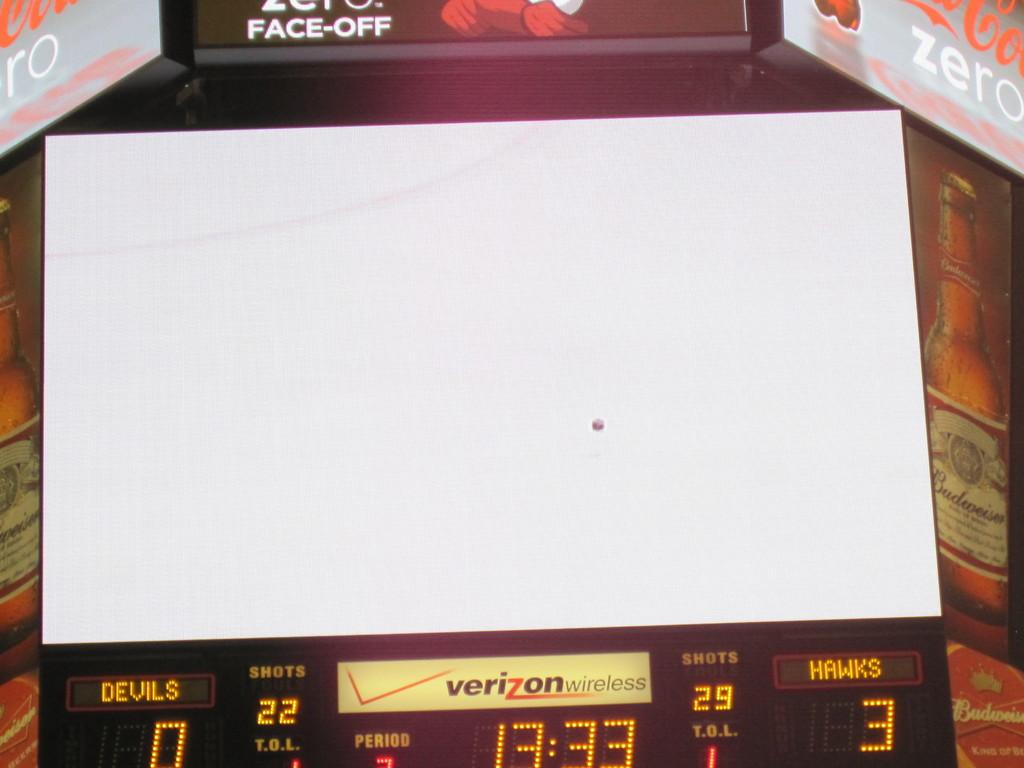<image>
Summarize the visual content of the image. A blank scoreboard is sponsored by Verizon Wireless. 